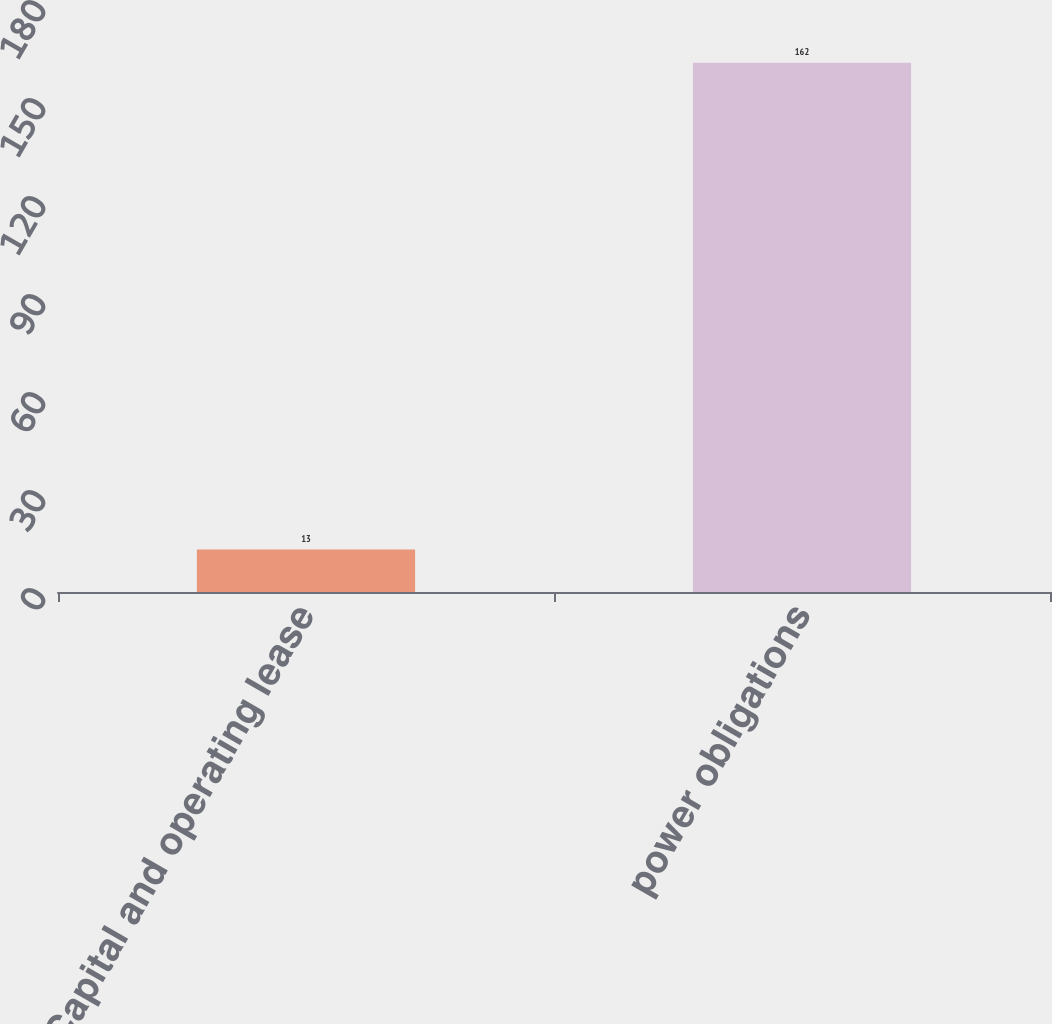Convert chart. <chart><loc_0><loc_0><loc_500><loc_500><bar_chart><fcel>Capital and operating lease<fcel>power obligations<nl><fcel>13<fcel>162<nl></chart> 